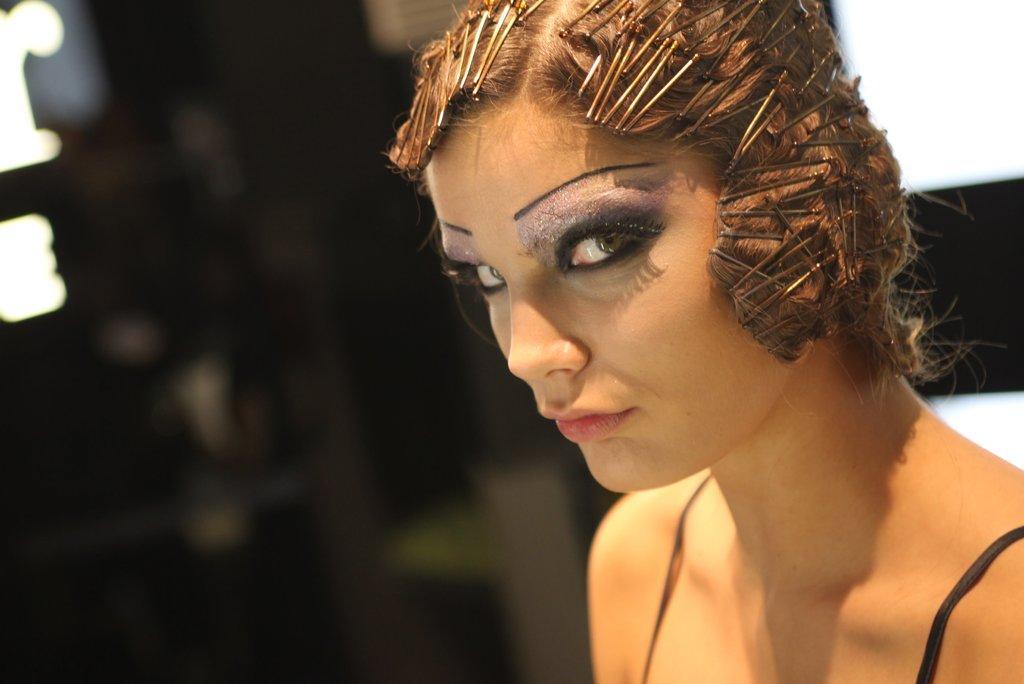Describe this image in one or two sentences. In this picture I can see the face of a person. 